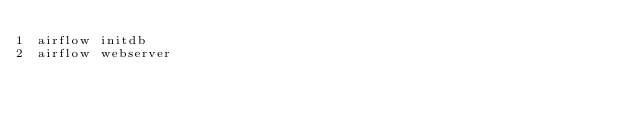Convert code to text. <code><loc_0><loc_0><loc_500><loc_500><_Bash_>airflow initdb
airflow webserver</code> 